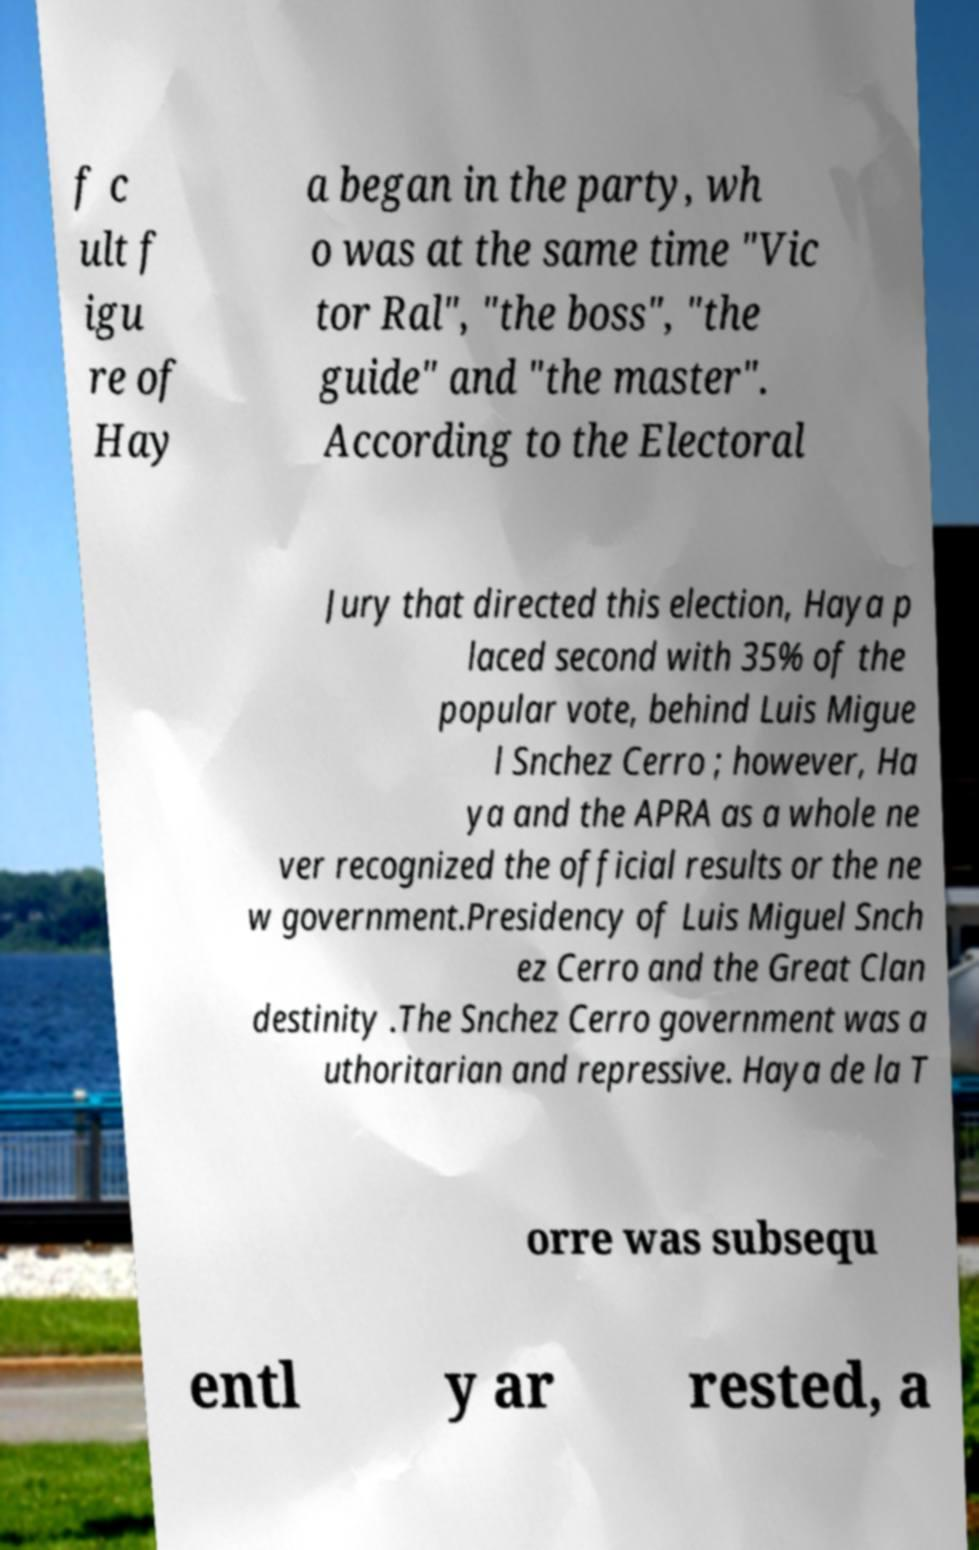Can you accurately transcribe the text from the provided image for me? f c ult f igu re of Hay a began in the party, wh o was at the same time "Vic tor Ral", "the boss", "the guide" and "the master". According to the Electoral Jury that directed this election, Haya p laced second with 35% of the popular vote, behind Luis Migue l Snchez Cerro ; however, Ha ya and the APRA as a whole ne ver recognized the official results or the ne w government.Presidency of Luis Miguel Snch ez Cerro and the Great Clan destinity .The Snchez Cerro government was a uthoritarian and repressive. Haya de la T orre was subsequ entl y ar rested, a 